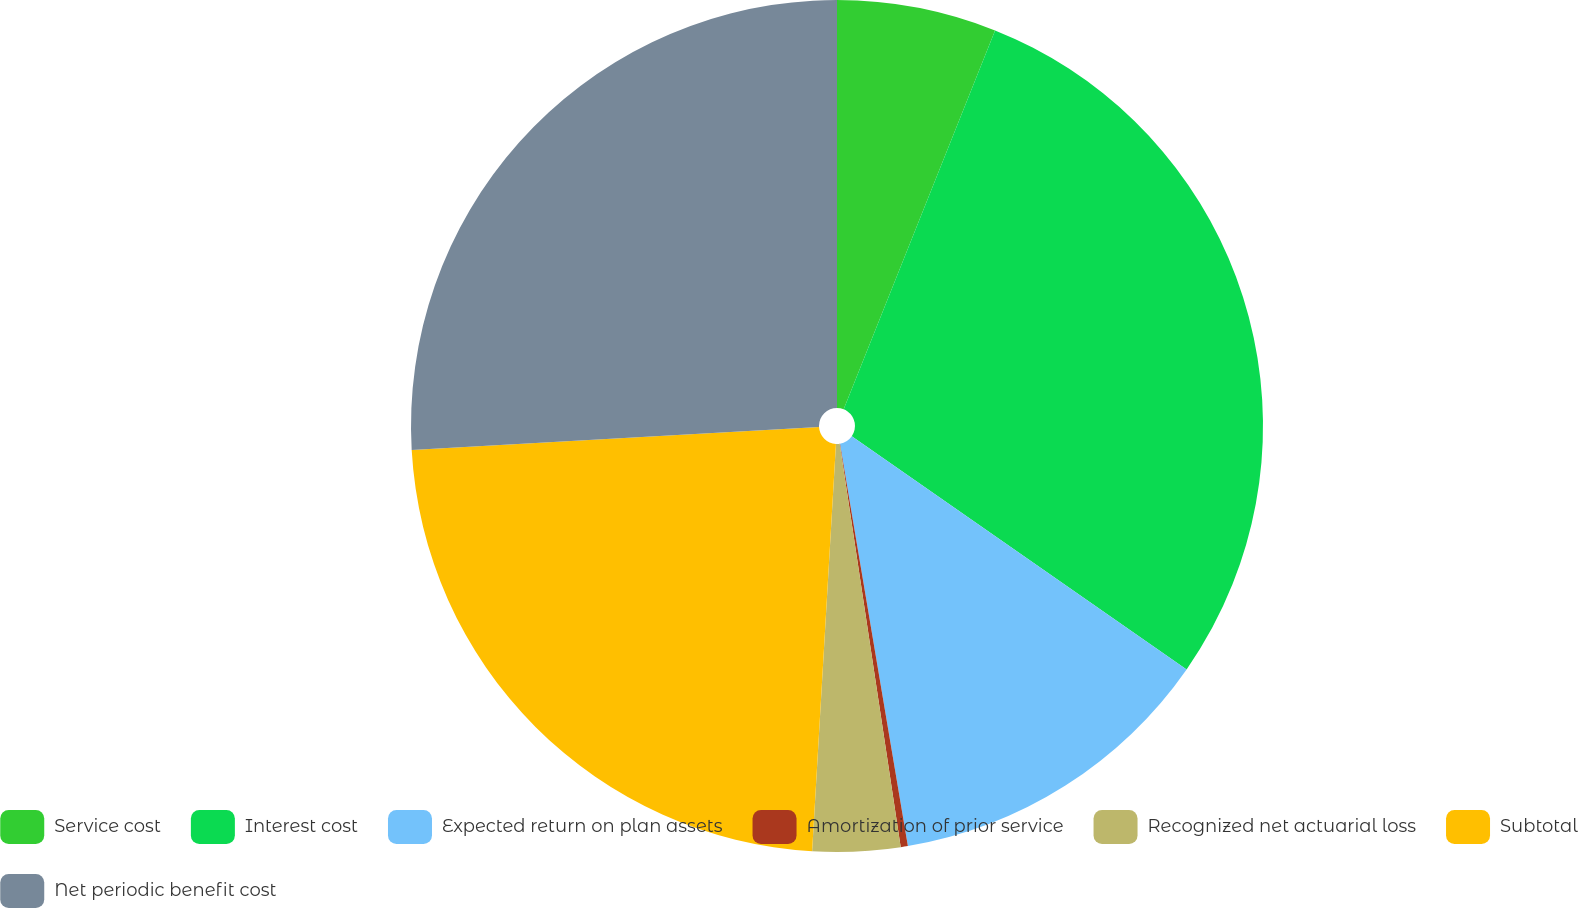<chart> <loc_0><loc_0><loc_500><loc_500><pie_chart><fcel>Service cost<fcel>Interest cost<fcel>Expected return on plan assets<fcel>Amortization of prior service<fcel>Recognized net actuarial loss<fcel>Subtotal<fcel>Net periodic benefit cost<nl><fcel>6.05%<fcel>28.63%<fcel>12.66%<fcel>0.27%<fcel>3.32%<fcel>23.17%<fcel>25.9%<nl></chart> 